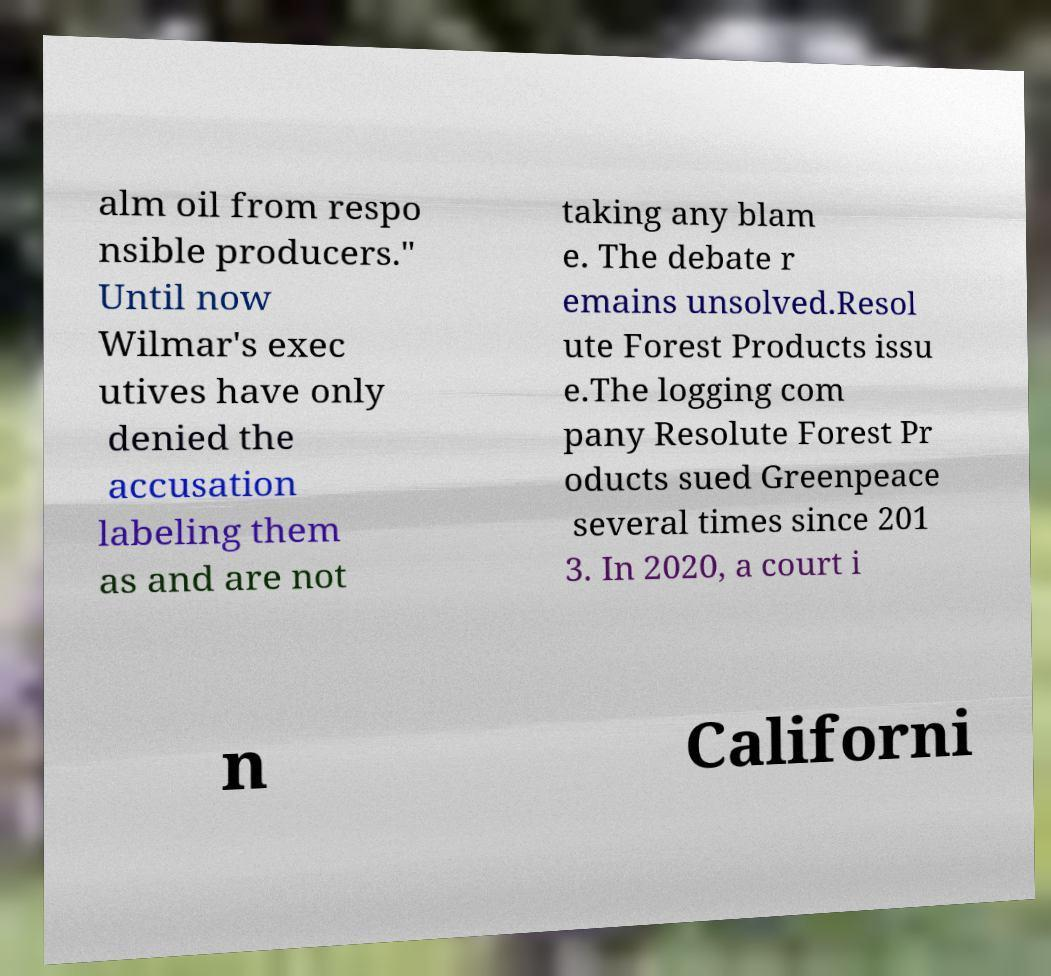Could you assist in decoding the text presented in this image and type it out clearly? alm oil from respo nsible producers." Until now Wilmar's exec utives have only denied the accusation labeling them as and are not taking any blam e. The debate r emains unsolved.Resol ute Forest Products issu e.The logging com pany Resolute Forest Pr oducts sued Greenpeace several times since 201 3. In 2020, a court i n Californi 